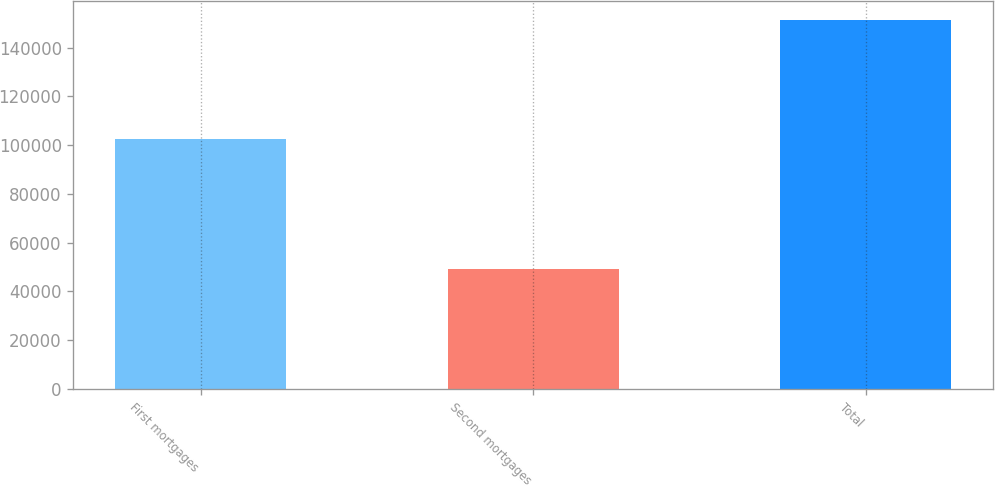Convert chart. <chart><loc_0><loc_0><loc_500><loc_500><bar_chart><fcel>First mortgages<fcel>Second mortgages<fcel>Total<nl><fcel>102489<fcel>48980<fcel>151469<nl></chart> 